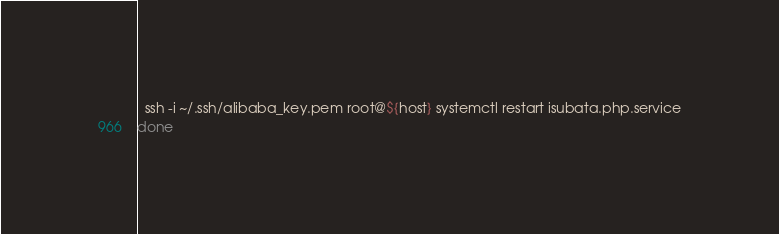Convert code to text. <code><loc_0><loc_0><loc_500><loc_500><_Bash_>  ssh -i ~/.ssh/alibaba_key.pem root@${host} systemctl restart isubata.php.service
done
</code> 